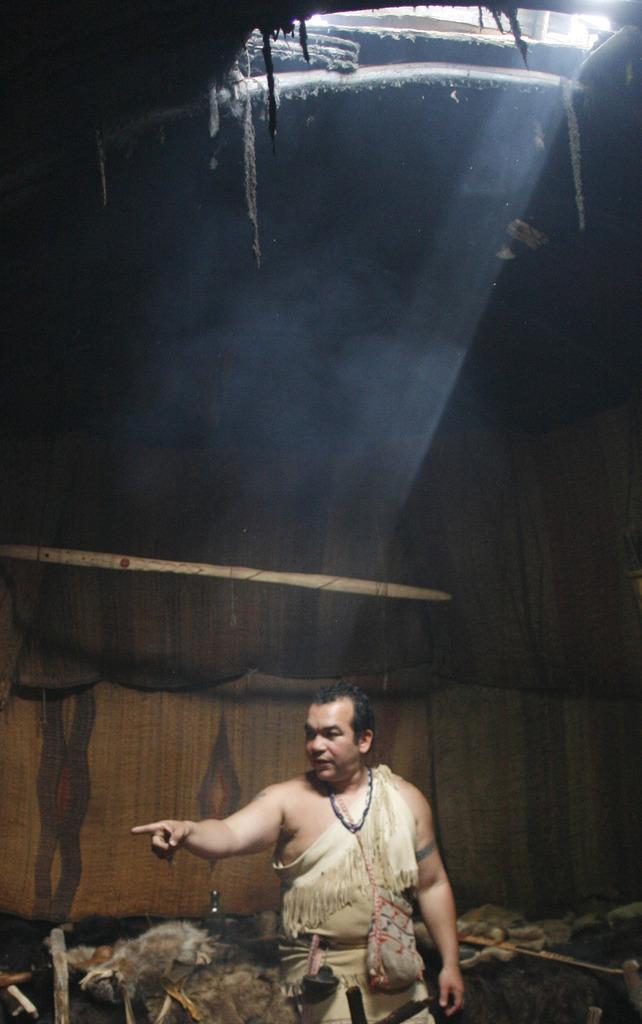In one or two sentences, can you explain what this image depicts? In this picture I can see a man standing and it looks like a tent. 